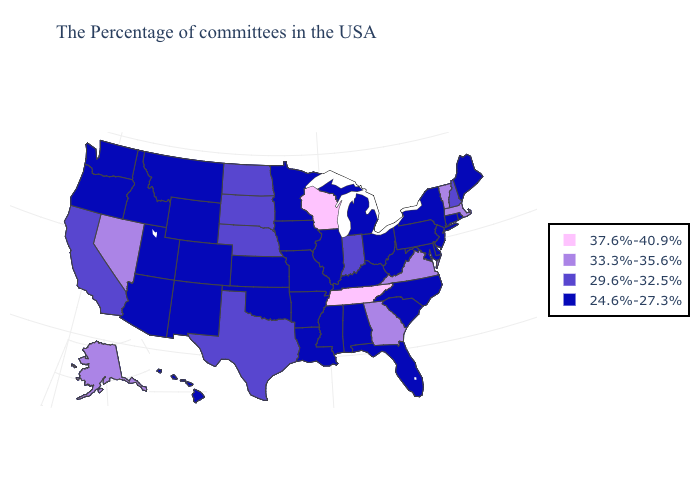Among the states that border North Dakota , which have the highest value?
Answer briefly. South Dakota. What is the highest value in the USA?
Short answer required. 37.6%-40.9%. What is the value of Maryland?
Quick response, please. 24.6%-27.3%. Does Arizona have the same value as Wisconsin?
Be succinct. No. Does Nevada have the highest value in the USA?
Concise answer only. No. Which states have the lowest value in the South?
Be succinct. Delaware, Maryland, North Carolina, South Carolina, West Virginia, Florida, Kentucky, Alabama, Mississippi, Louisiana, Arkansas, Oklahoma. Does Wisconsin have the highest value in the MidWest?
Short answer required. Yes. Does Virginia have the same value as Alaska?
Answer briefly. Yes. Name the states that have a value in the range 33.3%-35.6%?
Be succinct. Massachusetts, Vermont, Virginia, Georgia, Nevada, Alaska. What is the lowest value in the South?
Give a very brief answer. 24.6%-27.3%. Which states have the lowest value in the MidWest?
Be succinct. Ohio, Michigan, Illinois, Missouri, Minnesota, Iowa, Kansas. How many symbols are there in the legend?
Be succinct. 4. Which states have the lowest value in the MidWest?
Write a very short answer. Ohio, Michigan, Illinois, Missouri, Minnesota, Iowa, Kansas. How many symbols are there in the legend?
Give a very brief answer. 4. What is the value of Pennsylvania?
Be succinct. 24.6%-27.3%. 